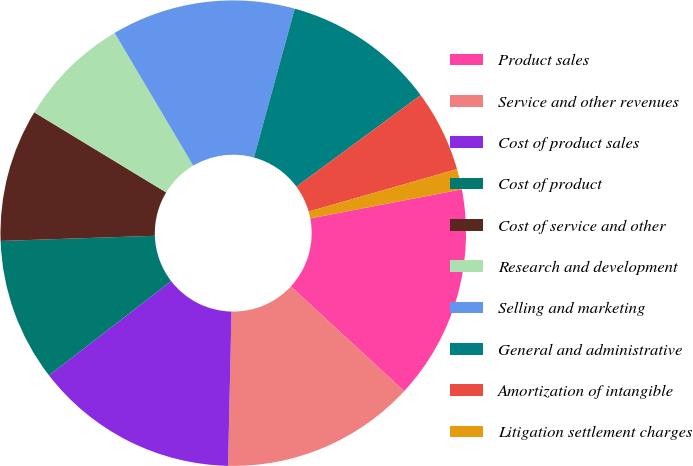Convert chart to OTSL. <chart><loc_0><loc_0><loc_500><loc_500><pie_chart><fcel>Product sales<fcel>Service and other revenues<fcel>Cost of product sales<fcel>Cost of product<fcel>Cost of service and other<fcel>Research and development<fcel>Selling and marketing<fcel>General and administrative<fcel>Amortization of intangible<fcel>Litigation settlement charges<nl><fcel>14.89%<fcel>13.48%<fcel>14.18%<fcel>9.93%<fcel>9.22%<fcel>7.8%<fcel>12.77%<fcel>10.64%<fcel>5.67%<fcel>1.42%<nl></chart> 